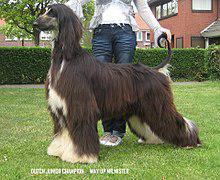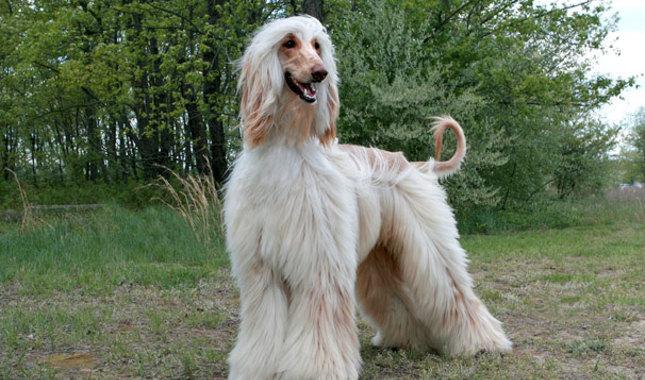The first image is the image on the left, the second image is the image on the right. Given the left and right images, does the statement "At least one image is of a dog from the shoulders up, looking toward the camera." hold true? Answer yes or no. No. The first image is the image on the left, the second image is the image on the right. Assess this claim about the two images: "In one image there is a lone afghan hound standing outside and facing the left side of the image.". Correct or not? Answer yes or no. Yes. 